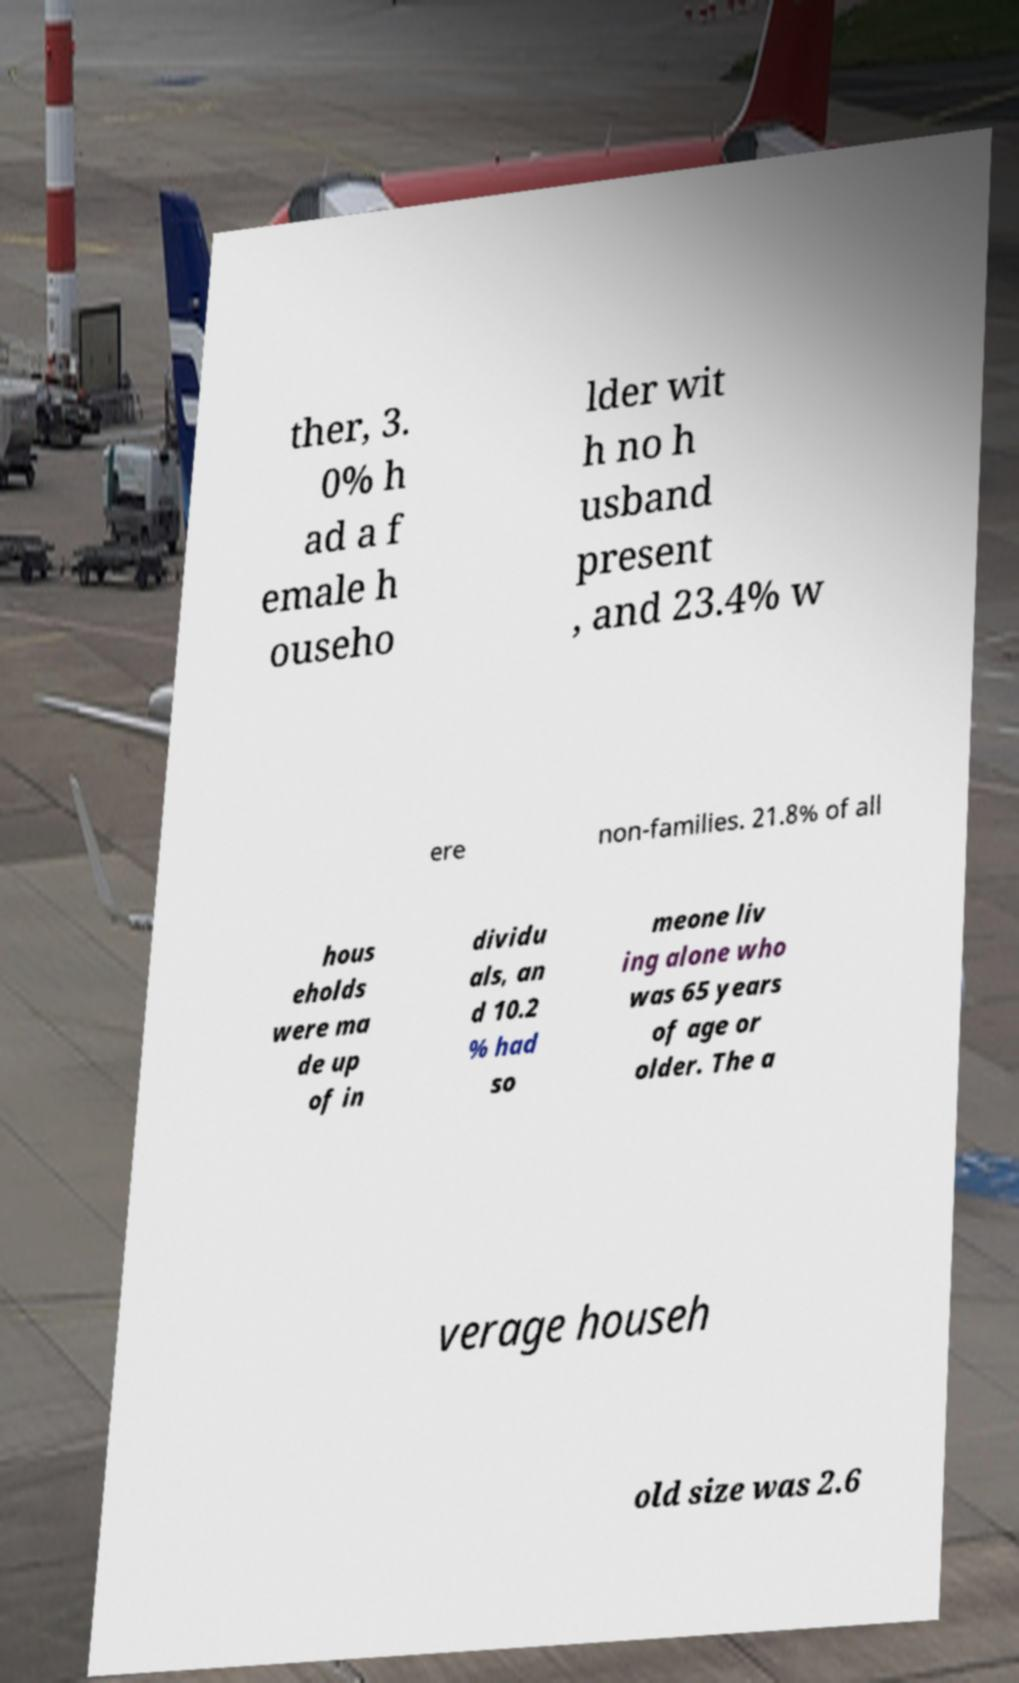Could you assist in decoding the text presented in this image and type it out clearly? ther, 3. 0% h ad a f emale h ouseho lder wit h no h usband present , and 23.4% w ere non-families. 21.8% of all hous eholds were ma de up of in dividu als, an d 10.2 % had so meone liv ing alone who was 65 years of age or older. The a verage househ old size was 2.6 